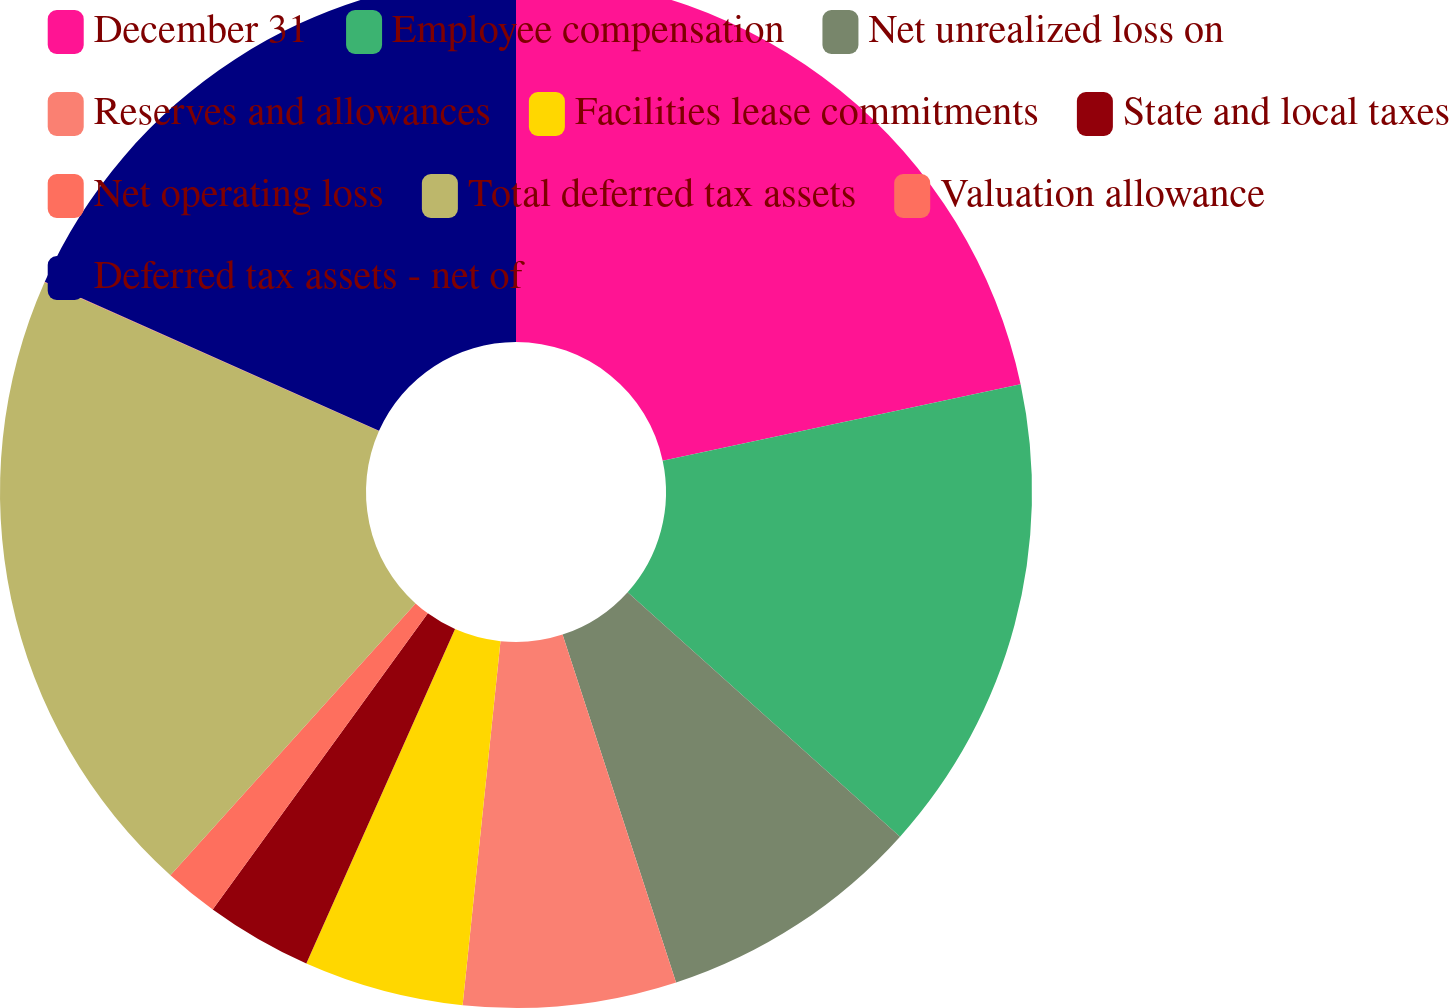<chart> <loc_0><loc_0><loc_500><loc_500><pie_chart><fcel>December 31<fcel>Employee compensation<fcel>Net unrealized loss on<fcel>Reserves and allowances<fcel>Facilities lease commitments<fcel>State and local taxes<fcel>Net operating loss<fcel>Total deferred tax assets<fcel>Valuation allowance<fcel>Deferred tax assets - net of<nl><fcel>21.65%<fcel>14.99%<fcel>8.34%<fcel>6.67%<fcel>5.01%<fcel>3.34%<fcel>1.68%<fcel>19.98%<fcel>0.02%<fcel>18.32%<nl></chart> 